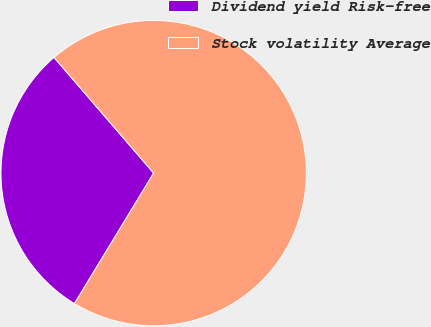Convert chart to OTSL. <chart><loc_0><loc_0><loc_500><loc_500><pie_chart><fcel>Dividend yield Risk-free<fcel>Stock volatility Average<nl><fcel>30.0%<fcel>70.0%<nl></chart> 